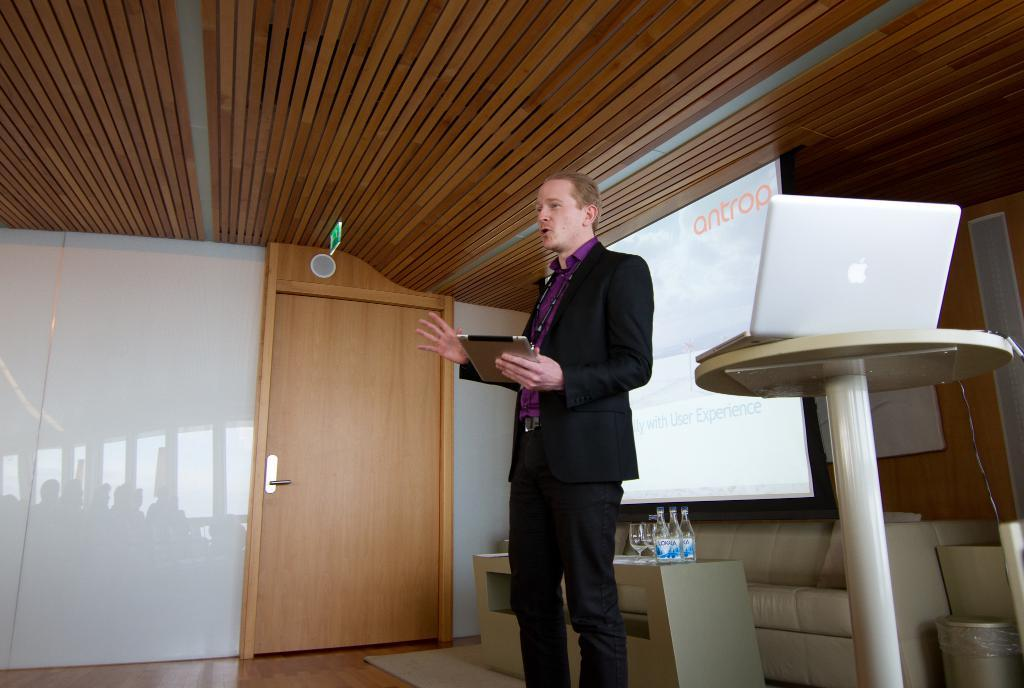What is the main subject of the image? There is a man standing in the center of the image. What is the man holding in the image? The man is holding a tab. What can be seen in the background of the image? There is a board, a table, a laptop, bottles, a glass, a couch, a door, and a wall visible in the background of the image. What type of magic trick is the man performing in the image? There is no indication of a magic trick being performed in the image. What kind of music can be heard coming from the box in the image? There is no box or music present in the image. 